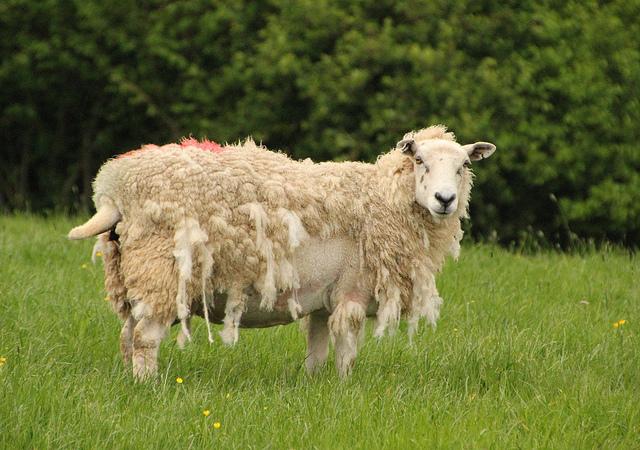Is the sheep bald?
Concise answer only. No. What color is the flowers on the grass?
Answer briefly. Yellow. What color are the tags on the sheep's ears?
Give a very brief answer. Black. What is the sheep looking at?
Write a very short answer. Camera. How many sheep are there?
Answer briefly. 1. What color are the sheeps sprayed?
Answer briefly. Red. How many animals are present?
Be succinct. 1. Is there a second sheep standing behind this one?
Write a very short answer. No. 